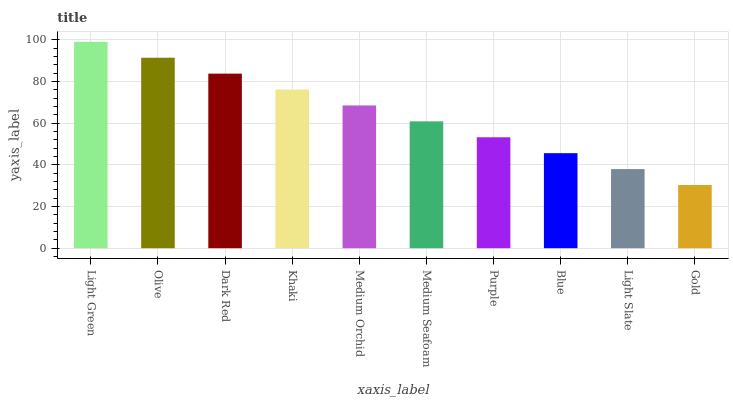Is Gold the minimum?
Answer yes or no. Yes. Is Light Green the maximum?
Answer yes or no. Yes. Is Olive the minimum?
Answer yes or no. No. Is Olive the maximum?
Answer yes or no. No. Is Light Green greater than Olive?
Answer yes or no. Yes. Is Olive less than Light Green?
Answer yes or no. Yes. Is Olive greater than Light Green?
Answer yes or no. No. Is Light Green less than Olive?
Answer yes or no. No. Is Medium Orchid the high median?
Answer yes or no. Yes. Is Medium Seafoam the low median?
Answer yes or no. Yes. Is Olive the high median?
Answer yes or no. No. Is Dark Red the low median?
Answer yes or no. No. 